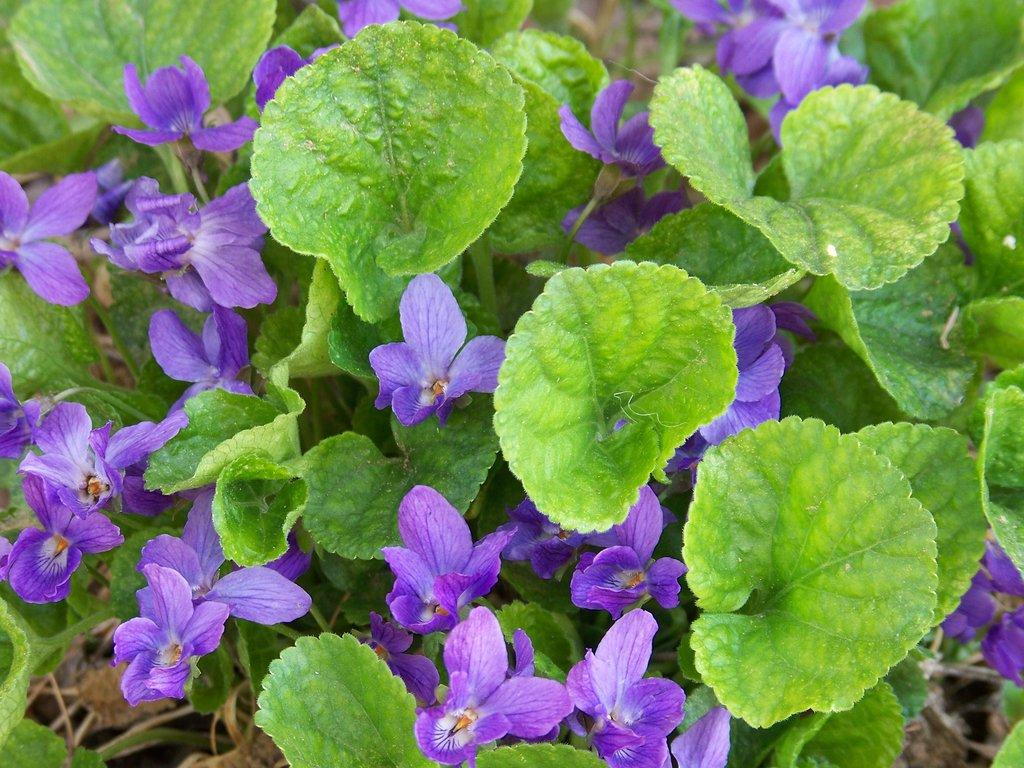What color are the flowers in the image? The flowers in the image are violet in color. What color are the leaves in the image? The leaves in the image are green in color. What is the income of the flowers in the image? There is no information about the income of the flowers in the image, as flowers do not have an income. 